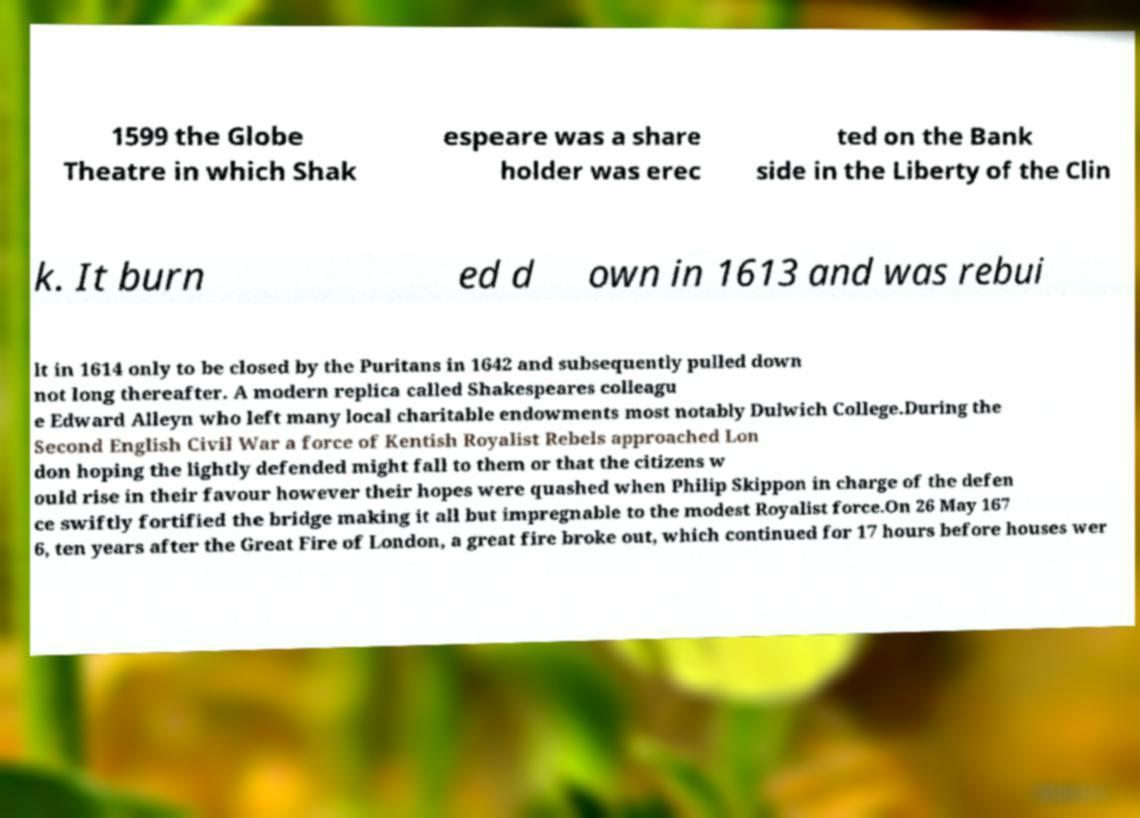I need the written content from this picture converted into text. Can you do that? 1599 the Globe Theatre in which Shak espeare was a share holder was erec ted on the Bank side in the Liberty of the Clin k. It burn ed d own in 1613 and was rebui lt in 1614 only to be closed by the Puritans in 1642 and subsequently pulled down not long thereafter. A modern replica called Shakespeares colleagu e Edward Alleyn who left many local charitable endowments most notably Dulwich College.During the Second English Civil War a force of Kentish Royalist Rebels approached Lon don hoping the lightly defended might fall to them or that the citizens w ould rise in their favour however their hopes were quashed when Philip Skippon in charge of the defen ce swiftly fortified the bridge making it all but impregnable to the modest Royalist force.On 26 May 167 6, ten years after the Great Fire of London, a great fire broke out, which continued for 17 hours before houses wer 